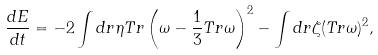<formula> <loc_0><loc_0><loc_500><loc_500>\frac { d E } { d t } = - 2 \int d r \eta T r \left ( \omega - \frac { 1 } { 3 } T r \omega \right ) ^ { 2 } - \int d r \zeta ( T r \omega ) ^ { 2 } ,</formula> 